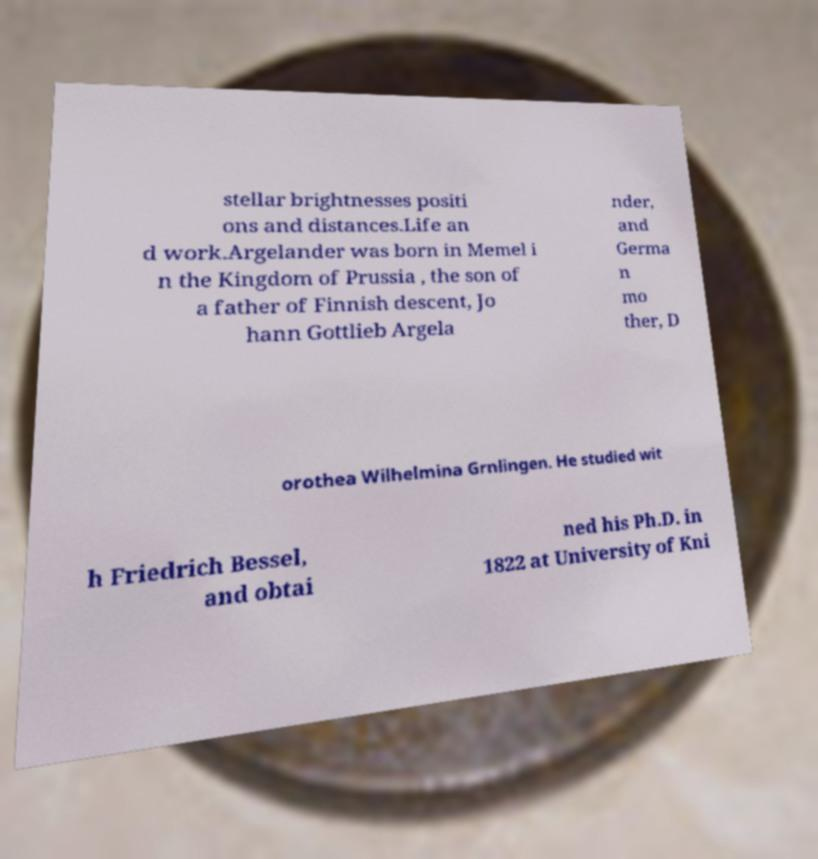Please read and relay the text visible in this image. What does it say? stellar brightnesses positi ons and distances.Life an d work.Argelander was born in Memel i n the Kingdom of Prussia , the son of a father of Finnish descent, Jo hann Gottlieb Argela nder, and Germa n mo ther, D orothea Wilhelmina Grnlingen. He studied wit h Friedrich Bessel, and obtai ned his Ph.D. in 1822 at University of Kni 